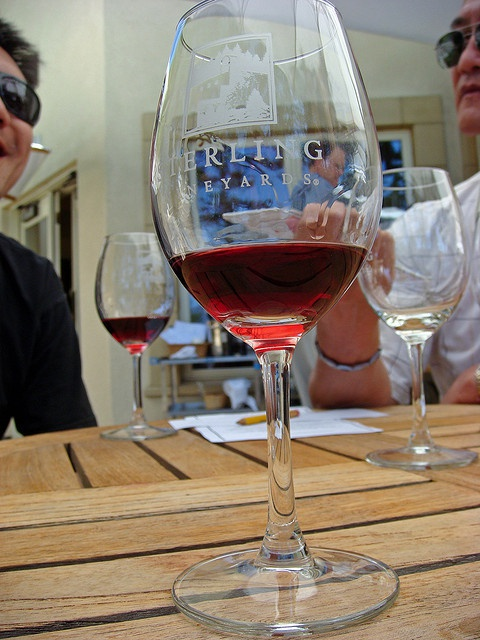Describe the objects in this image and their specific colors. I can see wine glass in darkgray, tan, black, and gray tones, dining table in darkgray, tan, and gray tones, people in darkgray, maroon, and gray tones, wine glass in darkgray, gray, and lightgray tones, and people in darkgray, black, brown, gray, and maroon tones in this image. 